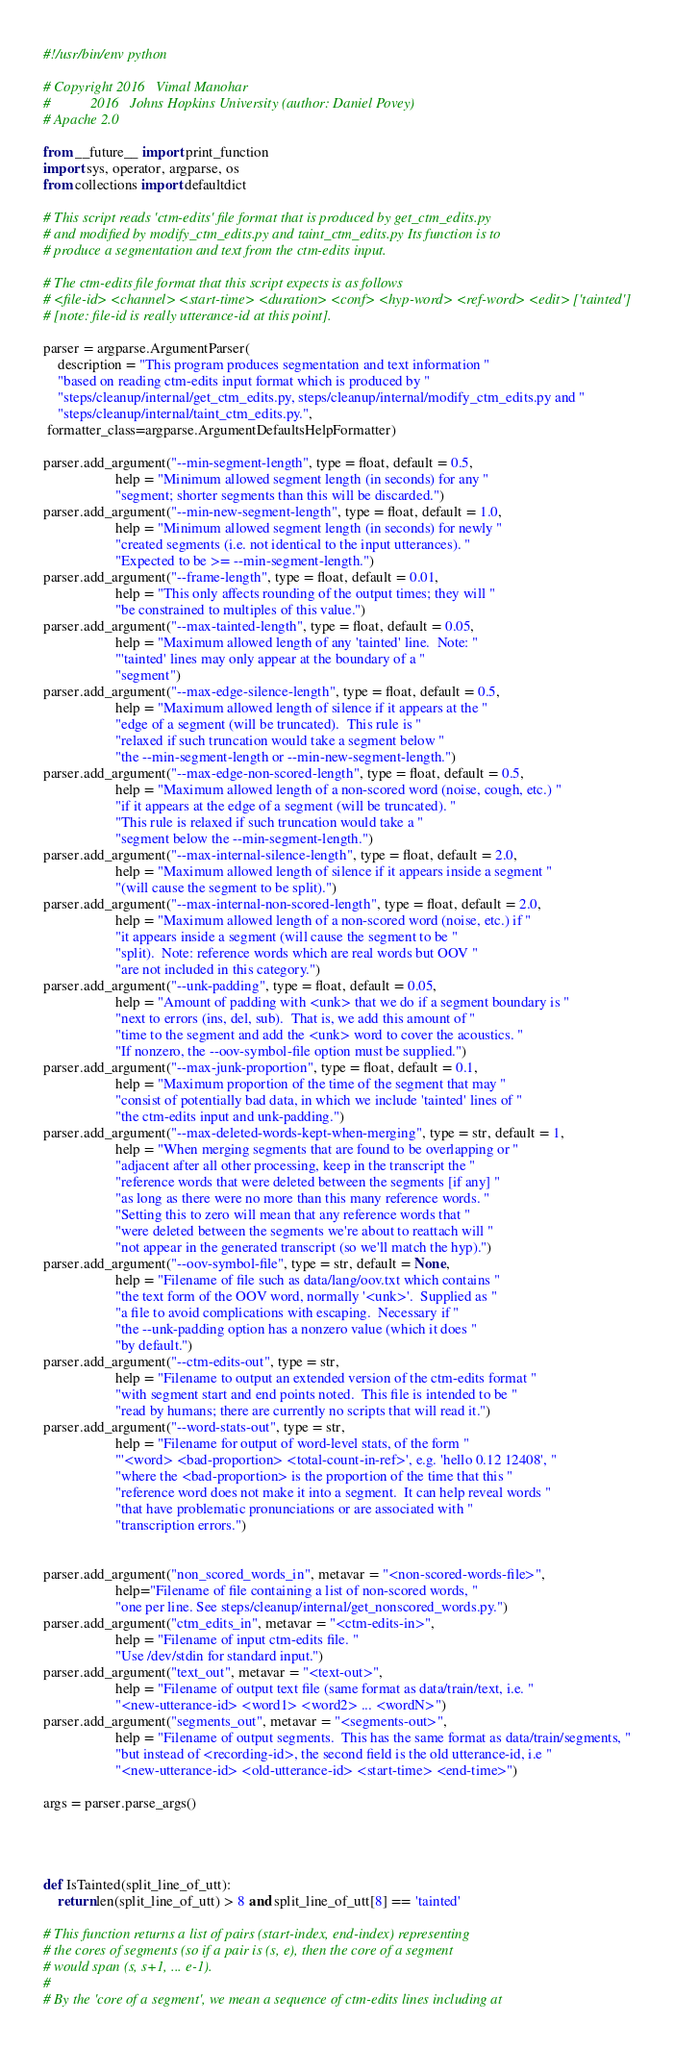<code> <loc_0><loc_0><loc_500><loc_500><_Python_>#!/usr/bin/env python

# Copyright 2016   Vimal Manohar
#           2016   Johns Hopkins University (author: Daniel Povey)
# Apache 2.0

from __future__ import print_function
import sys, operator, argparse, os
from collections import defaultdict

# This script reads 'ctm-edits' file format that is produced by get_ctm_edits.py
# and modified by modify_ctm_edits.py and taint_ctm_edits.py Its function is to
# produce a segmentation and text from the ctm-edits input.

# The ctm-edits file format that this script expects is as follows
# <file-id> <channel> <start-time> <duration> <conf> <hyp-word> <ref-word> <edit> ['tainted']
# [note: file-id is really utterance-id at this point].

parser = argparse.ArgumentParser(
    description = "This program produces segmentation and text information "
    "based on reading ctm-edits input format which is produced by "
    "steps/cleanup/internal/get_ctm_edits.py, steps/cleanup/internal/modify_ctm_edits.py and "
    "steps/cleanup/internal/taint_ctm_edits.py.",
 formatter_class=argparse.ArgumentDefaultsHelpFormatter)

parser.add_argument("--min-segment-length", type = float, default = 0.5,
                    help = "Minimum allowed segment length (in seconds) for any "
                    "segment; shorter segments than this will be discarded.")
parser.add_argument("--min-new-segment-length", type = float, default = 1.0,
                    help = "Minimum allowed segment length (in seconds) for newly "
                    "created segments (i.e. not identical to the input utterances). "
                    "Expected to be >= --min-segment-length.")
parser.add_argument("--frame-length", type = float, default = 0.01,
                    help = "This only affects rounding of the output times; they will "
                    "be constrained to multiples of this value.")
parser.add_argument("--max-tainted-length", type = float, default = 0.05,
                    help = "Maximum allowed length of any 'tainted' line.  Note: "
                    "'tainted' lines may only appear at the boundary of a "
                    "segment")
parser.add_argument("--max-edge-silence-length", type = float, default = 0.5,
                    help = "Maximum allowed length of silence if it appears at the "
                    "edge of a segment (will be truncated).  This rule is "
                    "relaxed if such truncation would take a segment below "
                    "the --min-segment-length or --min-new-segment-length.")
parser.add_argument("--max-edge-non-scored-length", type = float, default = 0.5,
                    help = "Maximum allowed length of a non-scored word (noise, cough, etc.) "
                    "if it appears at the edge of a segment (will be truncated). "
                    "This rule is relaxed if such truncation would take a "
                    "segment below the --min-segment-length.")
parser.add_argument("--max-internal-silence-length", type = float, default = 2.0,
                    help = "Maximum allowed length of silence if it appears inside a segment "
                    "(will cause the segment to be split).")
parser.add_argument("--max-internal-non-scored-length", type = float, default = 2.0,
                    help = "Maximum allowed length of a non-scored word (noise, etc.) if "
                    "it appears inside a segment (will cause the segment to be "
                    "split).  Note: reference words which are real words but OOV "
                    "are not included in this category.")
parser.add_argument("--unk-padding", type = float, default = 0.05,
                    help = "Amount of padding with <unk> that we do if a segment boundary is "
                    "next to errors (ins, del, sub).  That is, we add this amount of "
                    "time to the segment and add the <unk> word to cover the acoustics. "
                    "If nonzero, the --oov-symbol-file option must be supplied.")
parser.add_argument("--max-junk-proportion", type = float, default = 0.1,
                    help = "Maximum proportion of the time of the segment that may "
                    "consist of potentially bad data, in which we include 'tainted' lines of "
                    "the ctm-edits input and unk-padding.")
parser.add_argument("--max-deleted-words-kept-when-merging", type = str, default = 1,
                    help = "When merging segments that are found to be overlapping or "
                    "adjacent after all other processing, keep in the transcript the "
                    "reference words that were deleted between the segments [if any] "
                    "as long as there were no more than this many reference words. "
                    "Setting this to zero will mean that any reference words that "
                    "were deleted between the segments we're about to reattach will "
                    "not appear in the generated transcript (so we'll match the hyp).")
parser.add_argument("--oov-symbol-file", type = str, default = None,
                    help = "Filename of file such as data/lang/oov.txt which contains "
                    "the text form of the OOV word, normally '<unk>'.  Supplied as "
                    "a file to avoid complications with escaping.  Necessary if "
                    "the --unk-padding option has a nonzero value (which it does "
                    "by default.")
parser.add_argument("--ctm-edits-out", type = str,
                    help = "Filename to output an extended version of the ctm-edits format "
                    "with segment start and end points noted.  This file is intended to be "
                    "read by humans; there are currently no scripts that will read it.")
parser.add_argument("--word-stats-out", type = str,
                    help = "Filename for output of word-level stats, of the form "
                    "'<word> <bad-proportion> <total-count-in-ref>', e.g. 'hello 0.12 12408', "
                    "where the <bad-proportion> is the proportion of the time that this "
                    "reference word does not make it into a segment.  It can help reveal words "
                    "that have problematic pronunciations or are associated with "
                    "transcription errors.")


parser.add_argument("non_scored_words_in", metavar = "<non-scored-words-file>",
                    help="Filename of file containing a list of non-scored words, "
                    "one per line. See steps/cleanup/internal/get_nonscored_words.py.")
parser.add_argument("ctm_edits_in", metavar = "<ctm-edits-in>",
                    help = "Filename of input ctm-edits file. "
                    "Use /dev/stdin for standard input.")
parser.add_argument("text_out", metavar = "<text-out>",
                    help = "Filename of output text file (same format as data/train/text, i.e. "
                    "<new-utterance-id> <word1> <word2> ... <wordN>")
parser.add_argument("segments_out", metavar = "<segments-out>",
                    help = "Filename of output segments.  This has the same format as data/train/segments, "
                    "but instead of <recording-id>, the second field is the old utterance-id, i.e "
                    "<new-utterance-id> <old-utterance-id> <start-time> <end-time>")

args = parser.parse_args()




def IsTainted(split_line_of_utt):
    return len(split_line_of_utt) > 8 and split_line_of_utt[8] == 'tainted'

# This function returns a list of pairs (start-index, end-index) representing
# the cores of segments (so if a pair is (s, e), then the core of a segment
# would span (s, s+1, ... e-1).
#
# By the 'core of a segment', we mean a sequence of ctm-edits lines including at</code> 